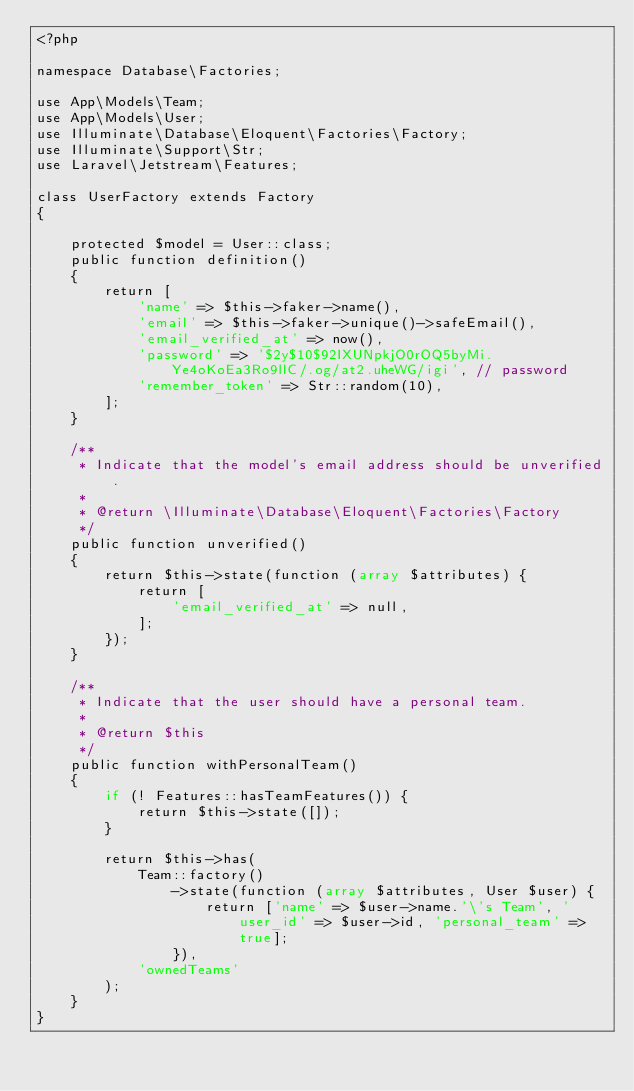<code> <loc_0><loc_0><loc_500><loc_500><_PHP_><?php

namespace Database\Factories;

use App\Models\Team;
use App\Models\User;
use Illuminate\Database\Eloquent\Factories\Factory;
use Illuminate\Support\Str;
use Laravel\Jetstream\Features;

class UserFactory extends Factory
{

    protected $model = User::class;
    public function definition()
    {
        return [
            'name' => $this->faker->name(),
            'email' => $this->faker->unique()->safeEmail(),
            'email_verified_at' => now(),
            'password' => '$2y$10$92IXUNpkjO0rOQ5byMi.Ye4oKoEa3Ro9llC/.og/at2.uheWG/igi', // password
            'remember_token' => Str::random(10),
        ];
    }

    /**
     * Indicate that the model's email address should be unverified.
     *
     * @return \Illuminate\Database\Eloquent\Factories\Factory
     */
    public function unverified()
    {
        return $this->state(function (array $attributes) {
            return [
                'email_verified_at' => null,
            ];
        });
    }

    /**
     * Indicate that the user should have a personal team.
     *
     * @return $this
     */
    public function withPersonalTeam()
    {
        if (! Features::hasTeamFeatures()) {
            return $this->state([]);
        }

        return $this->has(
            Team::factory()
                ->state(function (array $attributes, User $user) {
                    return ['name' => $user->name.'\'s Team', 'user_id' => $user->id, 'personal_team' => true];
                }),
            'ownedTeams'
        );
    }
}
</code> 